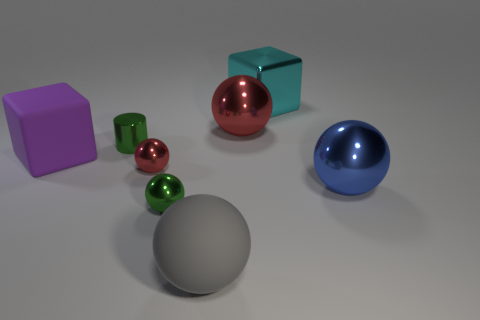Subtract all purple spheres. Subtract all brown blocks. How many spheres are left? 5 Add 2 blue objects. How many objects exist? 10 Subtract all cylinders. How many objects are left? 7 Subtract 0 green cubes. How many objects are left? 8 Subtract all big gray things. Subtract all tiny metallic balls. How many objects are left? 5 Add 3 big cyan things. How many big cyan things are left? 4 Add 1 small green metal spheres. How many small green metal spheres exist? 2 